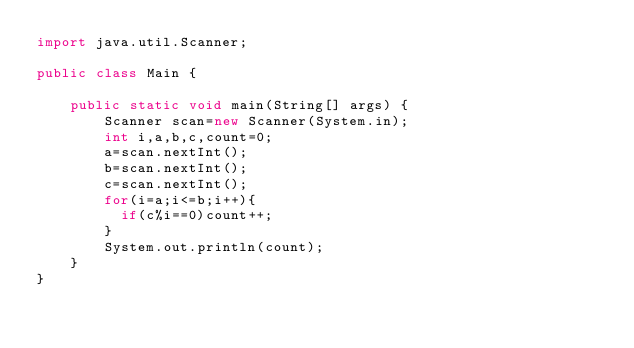Convert code to text. <code><loc_0><loc_0><loc_500><loc_500><_Java_>import java.util.Scanner;

public class Main {
   
    public static void main(String[] args) {
        Scanner scan=new Scanner(System.in);
        int i,a,b,c,count=0;
        a=scan.nextInt();
        b=scan.nextInt();
        c=scan.nextInt();
        for(i=a;i<=b;i++){
        	if(c%i==0)count++;
        }
        System.out.println(count);
    }
}</code> 